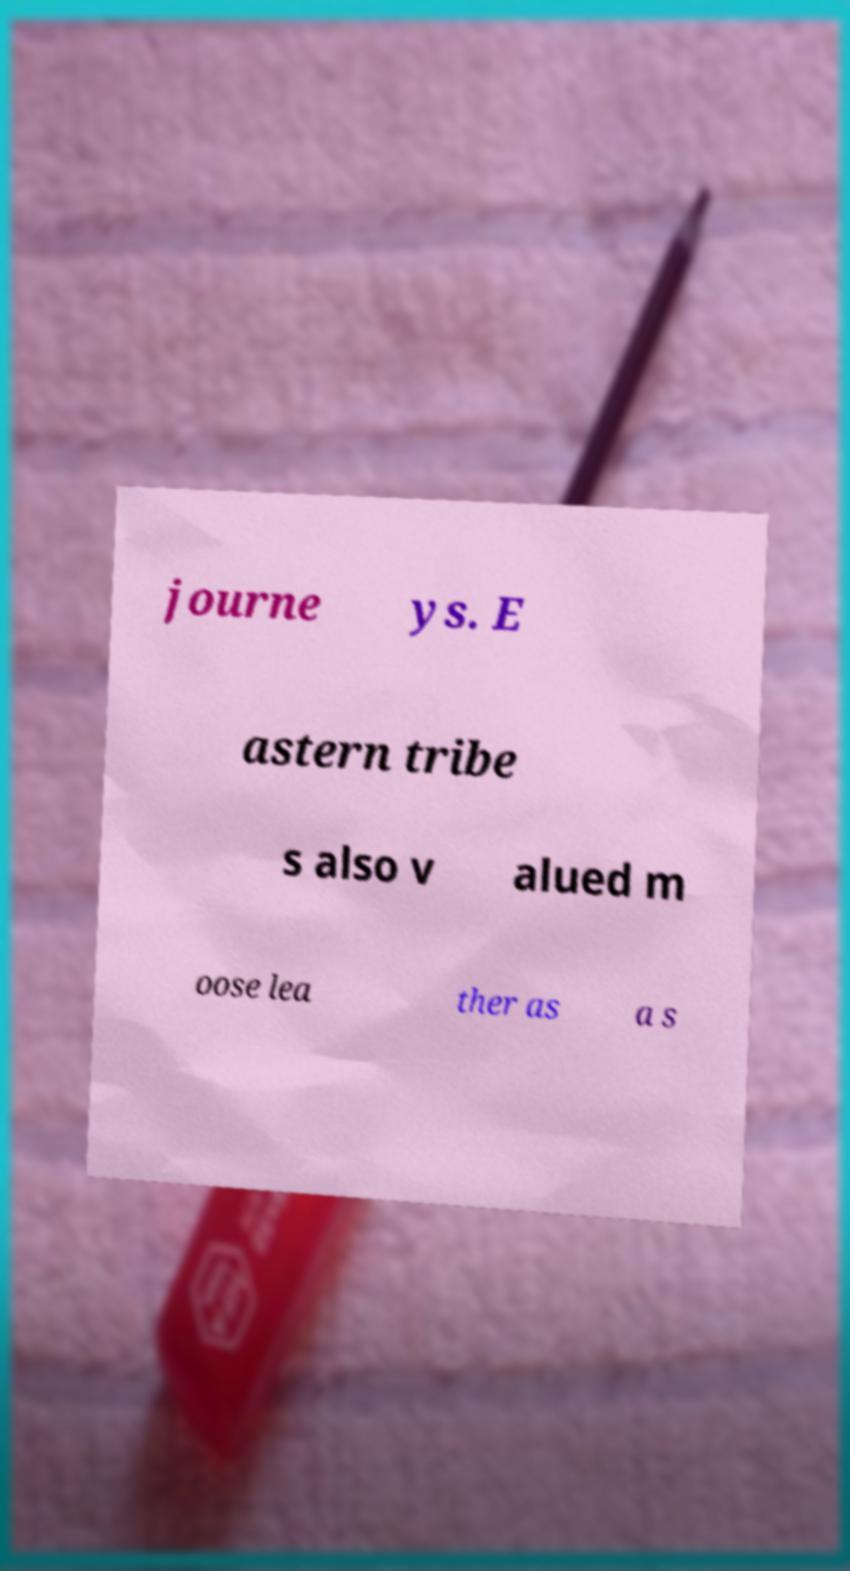Could you extract and type out the text from this image? journe ys. E astern tribe s also v alued m oose lea ther as a s 